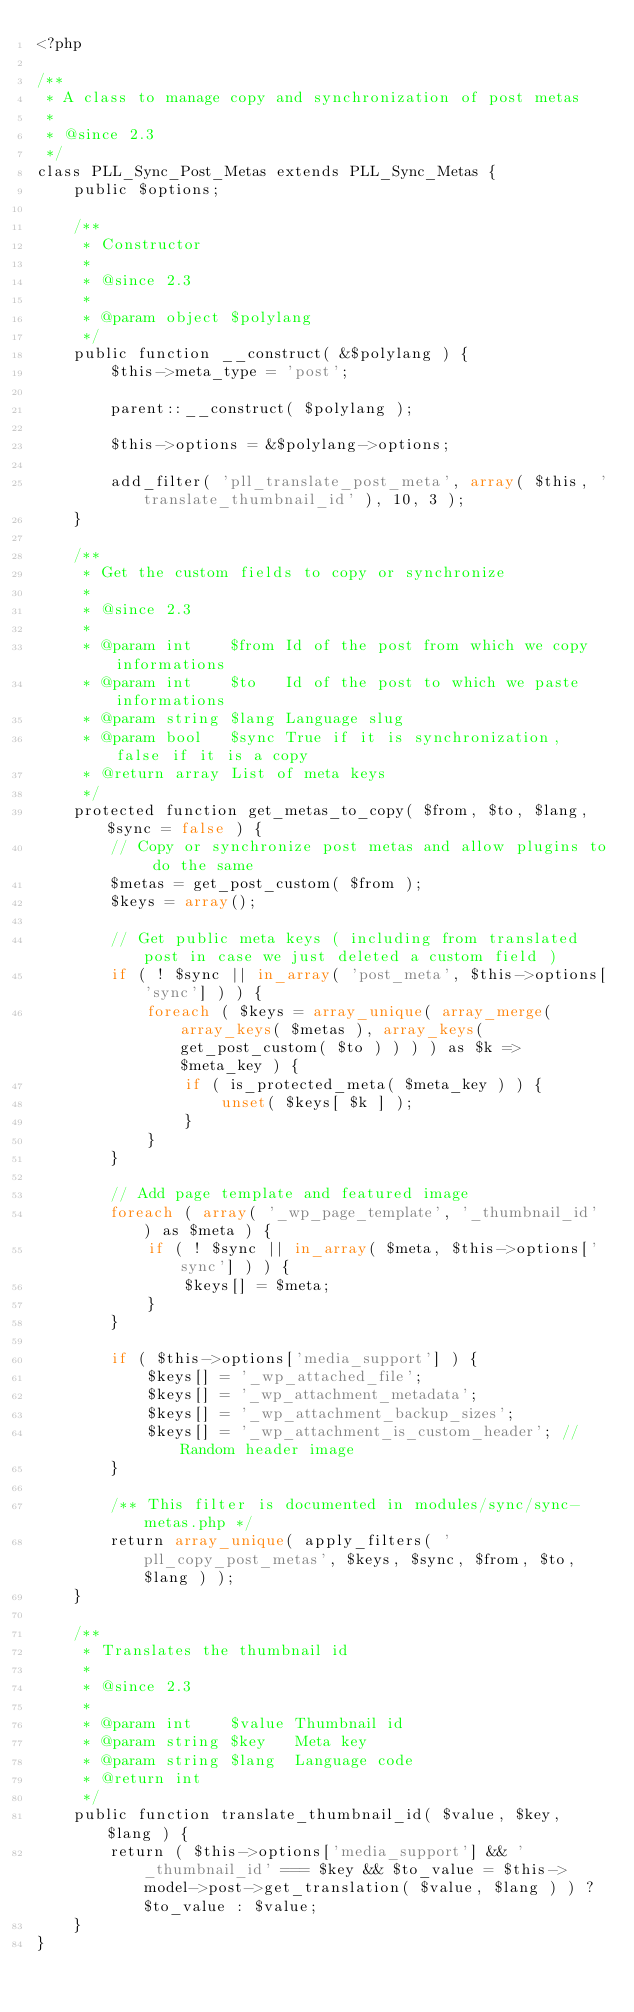Convert code to text. <code><loc_0><loc_0><loc_500><loc_500><_PHP_><?php

/**
 * A class to manage copy and synchronization of post metas
 *
 * @since 2.3
 */
class PLL_Sync_Post_Metas extends PLL_Sync_Metas {
	public $options;

	/**
	 * Constructor
	 *
	 * @since 2.3
	 *
	 * @param object $polylang
	 */
	public function __construct( &$polylang ) {
		$this->meta_type = 'post';

		parent::__construct( $polylang );

		$this->options = &$polylang->options;

		add_filter( 'pll_translate_post_meta', array( $this, 'translate_thumbnail_id' ), 10, 3 );
	}

	/**
	 * Get the custom fields to copy or synchronize
	 *
	 * @since 2.3
	 *
	 * @param int    $from Id of the post from which we copy informations
	 * @param int    $to   Id of the post to which we paste informations
	 * @param string $lang Language slug
	 * @param bool   $sync True if it is synchronization, false if it is a copy
	 * @return array List of meta keys
	 */
	protected function get_metas_to_copy( $from, $to, $lang, $sync = false ) {
		// Copy or synchronize post metas and allow plugins to do the same
		$metas = get_post_custom( $from );
		$keys = array();

		// Get public meta keys ( including from translated post in case we just deleted a custom field )
		if ( ! $sync || in_array( 'post_meta', $this->options['sync'] ) ) {
			foreach ( $keys = array_unique( array_merge( array_keys( $metas ), array_keys( get_post_custom( $to ) ) ) ) as $k => $meta_key ) {
				if ( is_protected_meta( $meta_key ) ) {
					unset( $keys[ $k ] );
				}
			}
		}

		// Add page template and featured image
		foreach ( array( '_wp_page_template', '_thumbnail_id' ) as $meta ) {
			if ( ! $sync || in_array( $meta, $this->options['sync'] ) ) {
				$keys[] = $meta;
			}
		}

		if ( $this->options['media_support'] ) {
			$keys[] = '_wp_attached_file';
			$keys[] = '_wp_attachment_metadata';
			$keys[] = '_wp_attachment_backup_sizes';
			$keys[] = '_wp_attachment_is_custom_header'; // Random header image
		}

		/** This filter is documented in modules/sync/sync-metas.php */
		return array_unique( apply_filters( 'pll_copy_post_metas', $keys, $sync, $from, $to, $lang ) );
	}

	/**
	 * Translates the thumbnail id
	 *
	 * @since 2.3
	 *
	 * @param int    $value Thumbnail id
	 * @param string $key   Meta key
	 * @param string $lang  Language code
	 * @return int
	 */
	public function translate_thumbnail_id( $value, $key, $lang ) {
		return ( $this->options['media_support'] && '_thumbnail_id' === $key && $to_value = $this->model->post->get_translation( $value, $lang ) ) ? $to_value : $value;
	}
}
</code> 